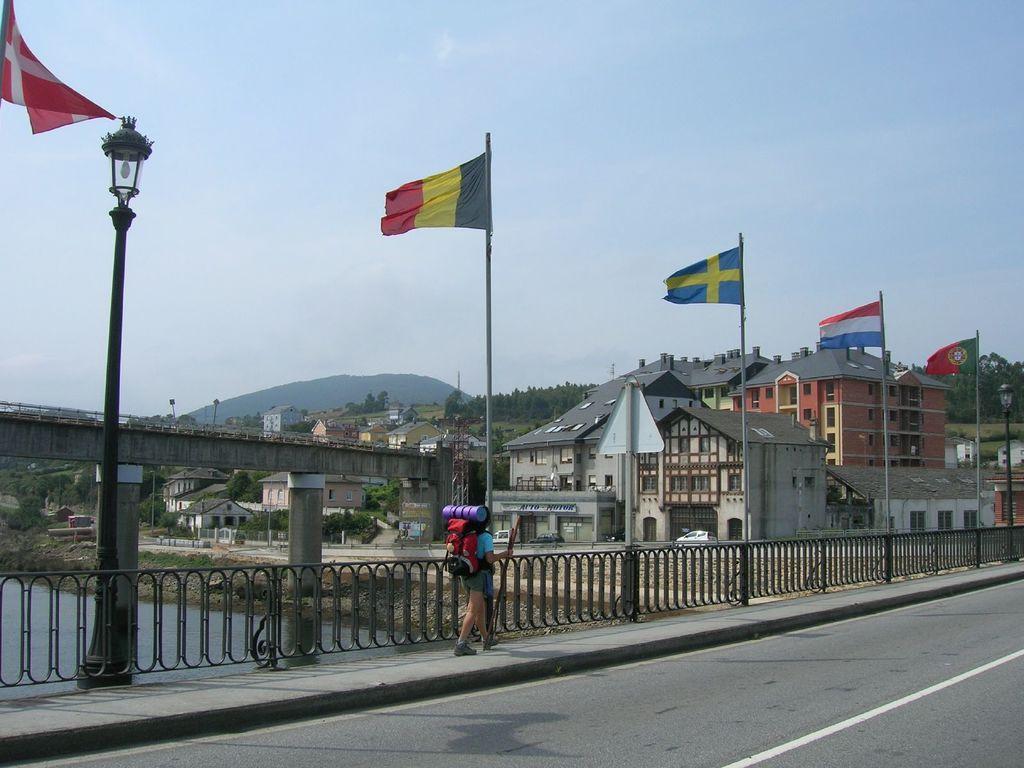Could you give a brief overview of what you see in this image? As we can see in the image there is fence, a man wearing bag, street lamp, flags, water, bridge, buildings, hills and sky. 